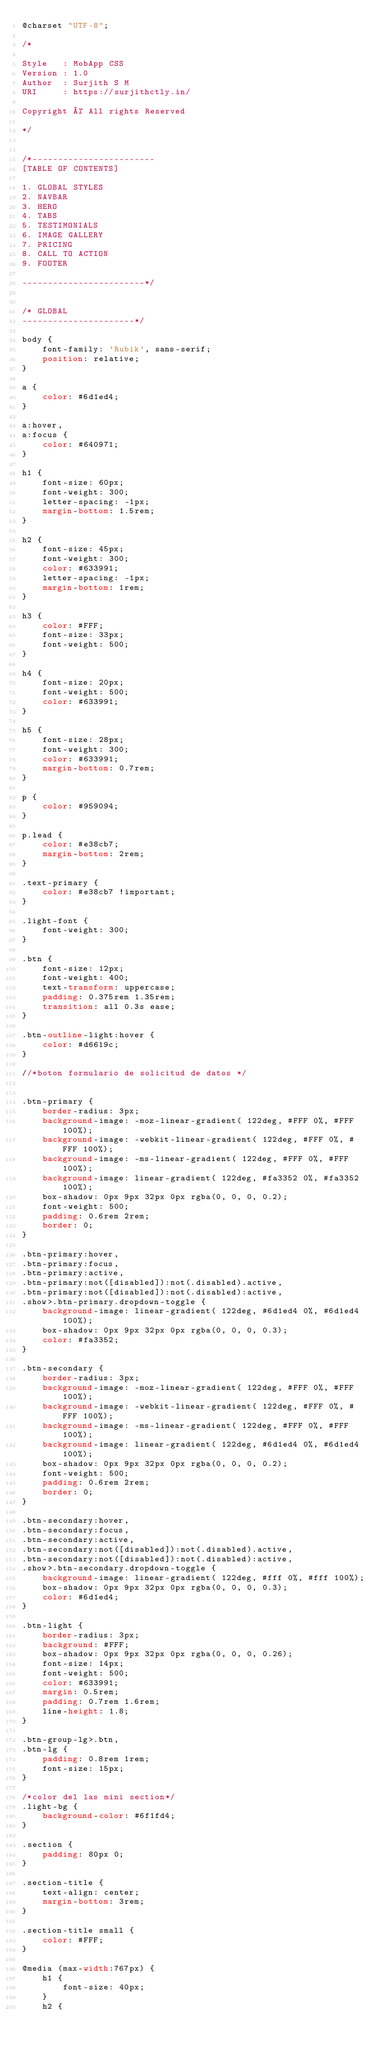<code> <loc_0><loc_0><loc_500><loc_500><_CSS_>@charset "UTF-8";

/*

Style   : MobApp CSS
Version : 1.0
Author  : Surjith S M
URI     : https://surjithctly.in/

Copyright © All rights Reserved 

*/


/*------------------------
[TABLE OF CONTENTS]
    
1. GLOBAL STYLES
2. NAVBAR
3. HERO
4. TABS
5. TESTIMONIALS
6. IMAGE GALLERY
7. PRICING
8. CALL TO ACTION
9. FOOTER

------------------------*/


/* GLOBAL
----------------------*/

body {
    font-family: 'Rubik', sans-serif;
    position: relative;
}

a {
    color: #6d1ed4;
}

a:hover,
a:focus {
    color: #640971;
}

h1 {
    font-size: 60px;
    font-weight: 300;
    letter-spacing: -1px;
    margin-bottom: 1.5rem;
}

h2 {
    font-size: 45px;
    font-weight: 300;
    color: #633991;
    letter-spacing: -1px;
    margin-bottom: 1rem;
}

h3 {
    color: #FFF;
    font-size: 33px;
    font-weight: 500;
}

h4 {
    font-size: 20px;
    font-weight: 500;
    color: #633991;
}

h5 {
    font-size: 28px;
    font-weight: 300;
    color: #633991;
    margin-bottom: 0.7rem;
}

p {
    color: #959094;
}

p.lead {
    color: #e38cb7;
    margin-bottom: 2rem;
}

.text-primary {
    color: #e38cb7 !important;
}

.light-font {
    font-weight: 300;
}

.btn {
    font-size: 12px;
    font-weight: 400;
    text-transform: uppercase;
    padding: 0.375rem 1.35rem;
    transition: all 0.3s ease;
}

.btn-outline-light:hover {
    color: #d6619c;
}

//*boton formulario de solicitud de datos */


.btn-primary {
    border-radius: 3px;
    background-image: -moz-linear-gradient( 122deg, #FFF 0%, #FFF 100%);
    background-image: -webkit-linear-gradient( 122deg, #FFF 0%, #FFF 100%);
    background-image: -ms-linear-gradient( 122deg, #FFF 0%, #FFF 100%);
    background-image: linear-gradient( 122deg, #fa3352 0%, #fa3352 100%);
    box-shadow: 0px 9px 32px 0px rgba(0, 0, 0, 0.2);
    font-weight: 500;
    padding: 0.6rem 2rem;
    border: 0;
}

.btn-primary:hover,
.btn-primary:focus,
.btn-primary:active,
.btn-primary:not([disabled]):not(.disabled).active,
.btn-primary:not([disabled]):not(.disabled):active,
.show>.btn-primary.dropdown-toggle {
    background-image: linear-gradient( 122deg, #6d1ed4 0%, #6d1ed4 100%);
    box-shadow: 0px 9px 32px 0px rgba(0, 0, 0, 0.3);
    color: #fa3352;
}

.btn-secondary {
    border-radius: 3px;
    background-image: -moz-linear-gradient( 122deg, #FFF 0%, #FFF 100%);
    background-image: -webkit-linear-gradient( 122deg, #FFF 0%, #FFF 100%);
    background-image: -ms-linear-gradient( 122deg, #FFF 0%, #FFF 100%);
    background-image: linear-gradient( 122deg, #6d1ed4 0%, #6d1ed4 100%);
    box-shadow: 0px 9px 32px 0px rgba(0, 0, 0, 0.2);
    font-weight: 500;
    padding: 0.6rem 2rem;
    border: 0;
}

.btn-secondary:hover,
.btn-secondary:focus,
.btn-secondary:active,
.btn-secondary:not([disabled]):not(.disabled).active,
.btn-secondary:not([disabled]):not(.disabled):active,
.show>.btn-secondary.dropdown-toggle {
    background-image: linear-gradient( 122deg, #fff 0%, #fff 100%);
    box-shadow: 0px 9px 32px 0px rgba(0, 0, 0, 0.3);
    color: #6d1ed4;
}

.btn-light {
    border-radius: 3px;
    background: #FFF;
    box-shadow: 0px 9px 32px 0px rgba(0, 0, 0, 0.26);
    font-size: 14px;
    font-weight: 500;
    color: #633991;
    margin: 0.5rem;
    padding: 0.7rem 1.6rem;
    line-height: 1.8;
}

.btn-group-lg>.btn,
.btn-lg {
    padding: 0.8rem 1rem;
    font-size: 15px;
}

/*color del las mini section*/
.light-bg {
    background-color: #6f1fd4;
}

.section {
    padding: 80px 0;
}

.section-title {
    text-align: center;
    margin-bottom: 3rem;
}

.section-title small {
    color: #FFF;
}

@media (max-width:767px) {
    h1 {
        font-size: 40px;
    }
    h2 {</code> 